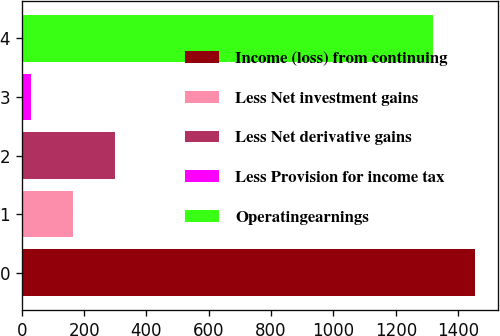Convert chart. <chart><loc_0><loc_0><loc_500><loc_500><bar_chart><fcel>Income (loss) from continuing<fcel>Less Net investment gains<fcel>Less Net derivative gains<fcel>Less Provision for income tax<fcel>Operatingearnings<nl><fcel>1455<fcel>165<fcel>299<fcel>31<fcel>1321<nl></chart> 